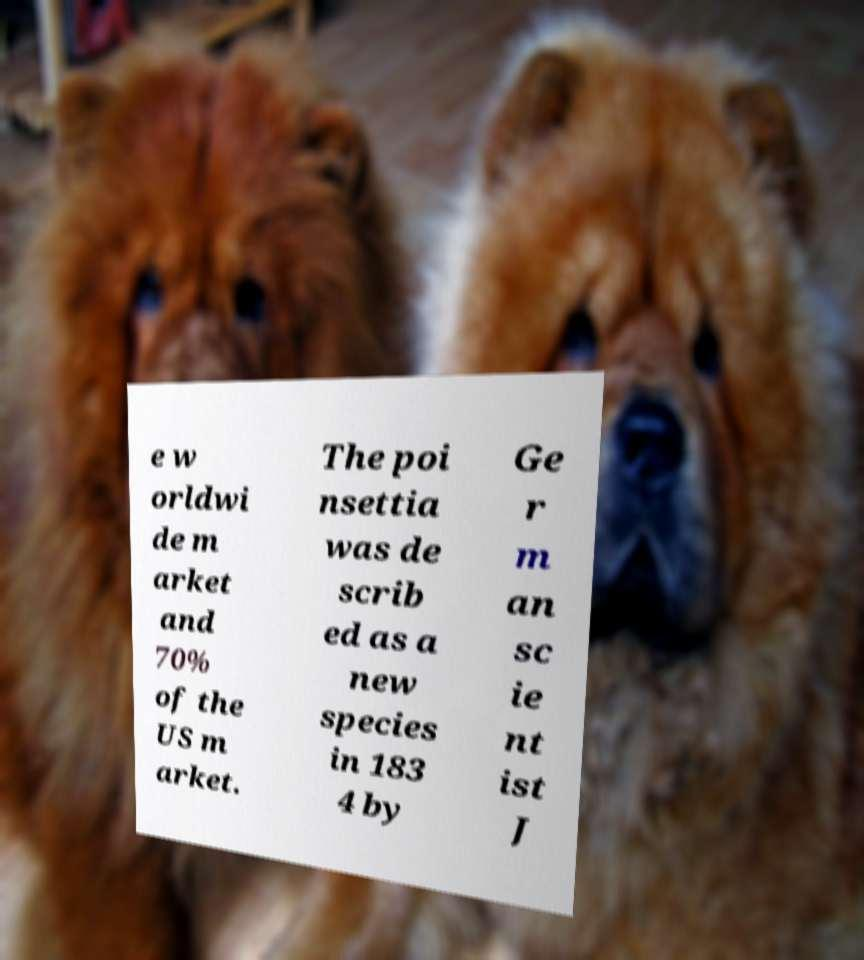For documentation purposes, I need the text within this image transcribed. Could you provide that? e w orldwi de m arket and 70% of the US m arket. The poi nsettia was de scrib ed as a new species in 183 4 by Ge r m an sc ie nt ist J 